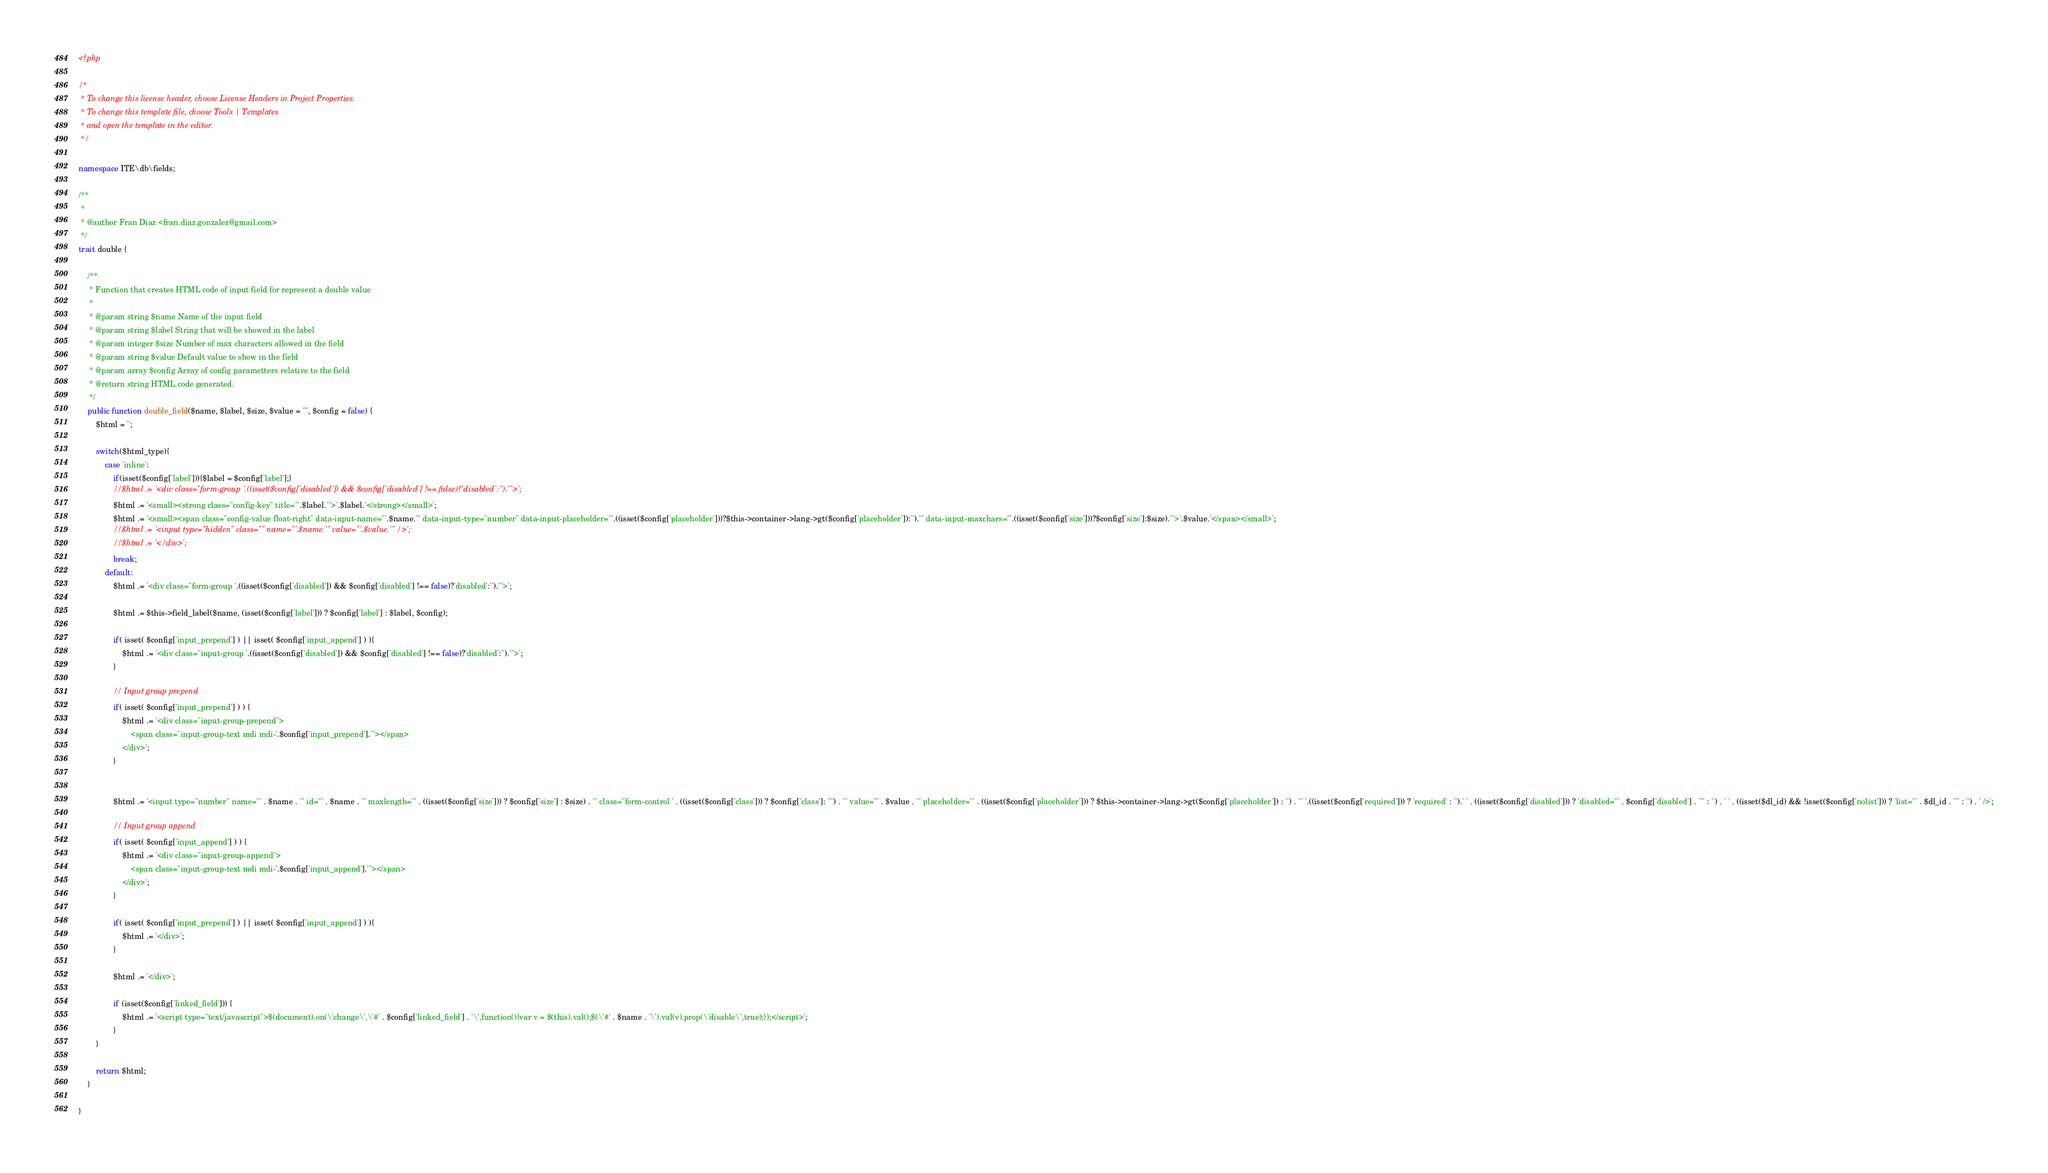Convert code to text. <code><loc_0><loc_0><loc_500><loc_500><_PHP_><?php

/*
 * To change this license header, choose License Headers in Project Properties.
 * To change this template file, choose Tools | Templates
 * and open the template in the editor.
 */

namespace ITE\db\fields;

/**
 *
 * @author Fran Díaz <fran.diaz.gonzalez@gmail.com>
 */
trait double {
    
    /**
     * Function that creates HTML code of input field for represent a double value
     * 
     * @param string $name Name of the input field
     * @param string $label String that will be showed in the label
     * @param integer $size Number of max characters allowed in the field
     * @param string $value Default value to show in the field
     * @param array $config Array of config parametters relative to the field 
     * @return string HTML code generated.
     */
    public function double_field($name, $label, $size, $value = "", $config = false) {
        $html = '';
        
        switch($html_type){
            case 'inline':
                if(isset($config['label'])){$label = $config['label'];}
                //$html .= '<div class="form-group '.((isset($config['disabled']) && $config['disabled'] !== false)?'disabled':'').'">';
                $html .= '<small><strong class="config-key" title="'.$label.'">'.$label.'</strong></small>';
                $html .= '<small><span class="config-value float-right" data-input-name="'.$name.'" data-input-type="number" data-input-placeholder="'.((isset($config['placeholder']))?$this->container->lang->gt($config['placeholder']):'').'" data-input-maxchars="'.((isset($config['size']))?$config['size']:$size).'">'.$value.'</span></small>';
                //$html .= '<input type="hidden" class="" name="'.$name.'" value="'.$value.'" />';
                //$html .= '</div>';
                break;
            default:
                $html .= '<div class="form-group '.((isset($config['disabled']) && $config['disabled'] !== false)?'disabled':'').'">';

                $html .= $this->field_label($name, (isset($config['label'])) ? $config['label'] : $label, $config);
                
                if( isset( $config['input_prepend'] ) || isset( $config['input_append'] ) ){
                    $html .= '<div class="input-group '.((isset($config['disabled']) && $config['disabled'] !== false)?'disabled':'').'">';
                }

                // Input group prepend
                if( isset( $config['input_prepend'] ) ) {
                    $html .= '<div class="input-group-prepend">
                        <span class="input-group-text mdi mdi-'.$config['input_prepend'].'"></span>
                    </div>';
                }

                
                $html .= '<input type="number" name="' . $name . '" id="' . $name . '" maxlength="' . ((isset($config['size'])) ? $config['size'] : $size) . '" class="form-control ' . ((isset($config['class'])) ? $config['class']: "") . '" value="' . $value . '" placeholder="' . ((isset($config['placeholder'])) ? $this->container->lang->gt($config['placeholder']) : '') . '" '.((isset($config['required'])) ? 'required' : '').' ' . ((isset($config['disabled'])) ? 'disabled="' . $config['disabled'] . '"' : '') . ' ' . ((isset($dl_id) && !isset($config['nolist'])) ? 'list="' . $dl_id . '"' : '') . ' />';

                // Input group append
                if( isset( $config['input_append'] ) ) {
                    $html .= '<div class="input-group-append">
                        <span class="input-group-text mdi mdi-'.$config['input_append'].'"></span>
                    </div>';
                }

                if( isset( $config['input_prepend'] ) || isset( $config['input_append'] ) ){
                    $html .= '</div>';
                }

                $html .= '</div>';

                if (isset($config['linked_field'])) {
                    $html .= '<script type="text/javascript">$(document).on(\'change\',\'#' . $config['linked_field'] . '\',function(){var v = $(this).val();$(\'#' . $name . '\').val(v).prop(\'disable\',true);});</script>';
                }
        }

        return $html;
    }
    
}
</code> 